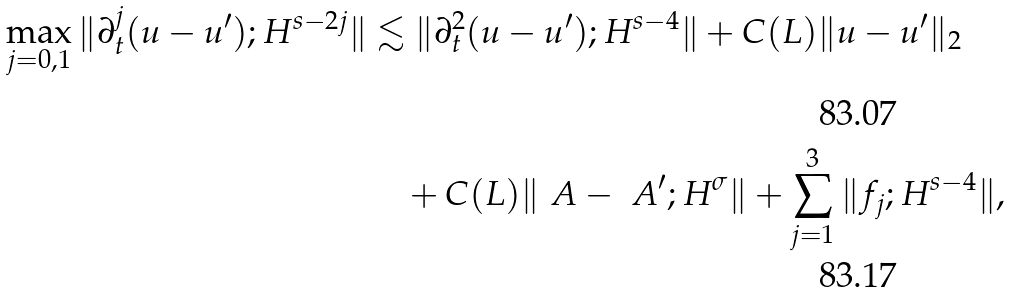Convert formula to latex. <formula><loc_0><loc_0><loc_500><loc_500>\max _ { j = 0 , 1 } \| \partial _ { t } ^ { j } ( u - u ^ { \prime } ) ; H ^ { s - 2 j } \| & \lesssim \| \partial _ { t } ^ { 2 } ( u - u ^ { \prime } ) ; H ^ { s - 4 } \| + C ( L ) \| u - u ^ { \prime } \| _ { 2 } \\ & \quad + C ( L ) \| \ A - \ A ^ { \prime } ; H ^ { \sigma } \| + \sum _ { j = 1 } ^ { 3 } \| f _ { j } ; H ^ { s - 4 } \| ,</formula> 